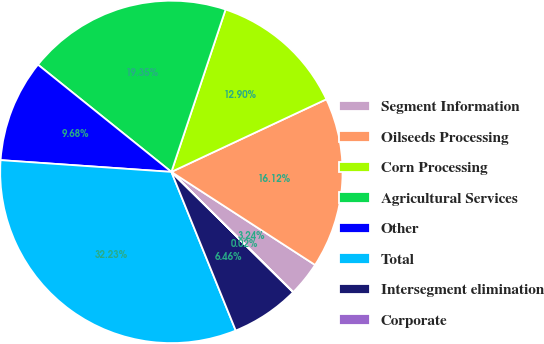Convert chart to OTSL. <chart><loc_0><loc_0><loc_500><loc_500><pie_chart><fcel>Segment Information<fcel>Oilseeds Processing<fcel>Corn Processing<fcel>Agricultural Services<fcel>Other<fcel>Total<fcel>Intersegment elimination<fcel>Corporate<nl><fcel>3.24%<fcel>16.12%<fcel>12.9%<fcel>19.35%<fcel>9.68%<fcel>32.23%<fcel>6.46%<fcel>0.02%<nl></chart> 